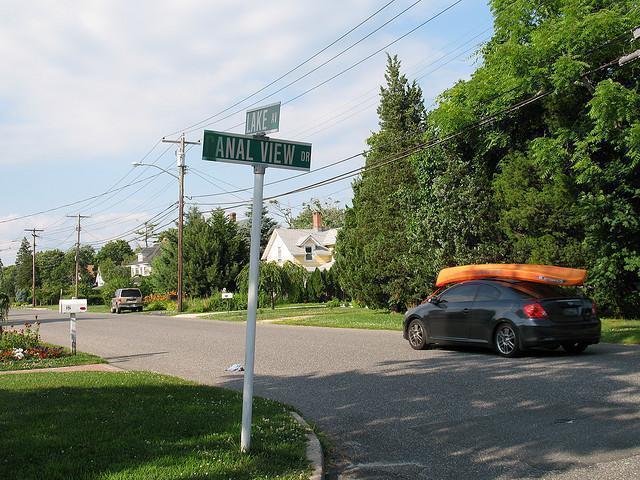What type of tool do you need to move while in the object on top of the black car?
Select the accurate answer and provide justification: `Answer: choice
Rationale: srationale.`
Options: Car keys, sun glasses, swimming trunks, paddle. Answer: paddle.
Rationale: You will need a paddle to row the boat. 